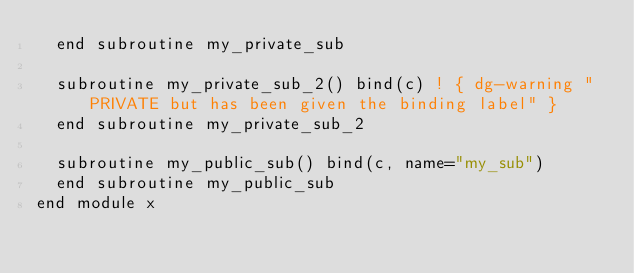Convert code to text. <code><loc_0><loc_0><loc_500><loc_500><_FORTRAN_>  end subroutine my_private_sub

  subroutine my_private_sub_2() bind(c) ! { dg-warning "PRIVATE but has been given the binding label" }
  end subroutine my_private_sub_2

  subroutine my_public_sub() bind(c, name="my_sub")
  end subroutine my_public_sub
end module x
</code> 